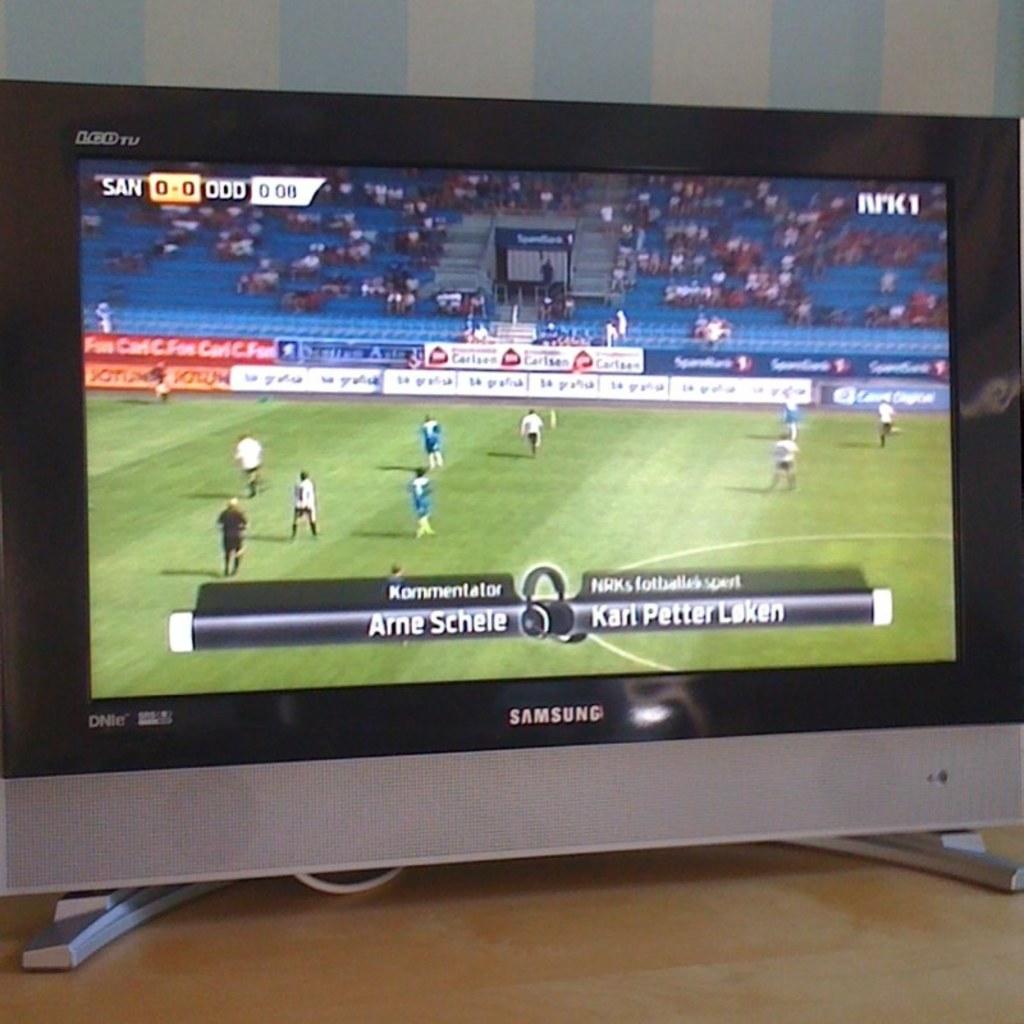What is the brand of this tv?
Your answer should be very brief. Samsung. How much time is left in the game?
Provide a succinct answer. 0:08. 